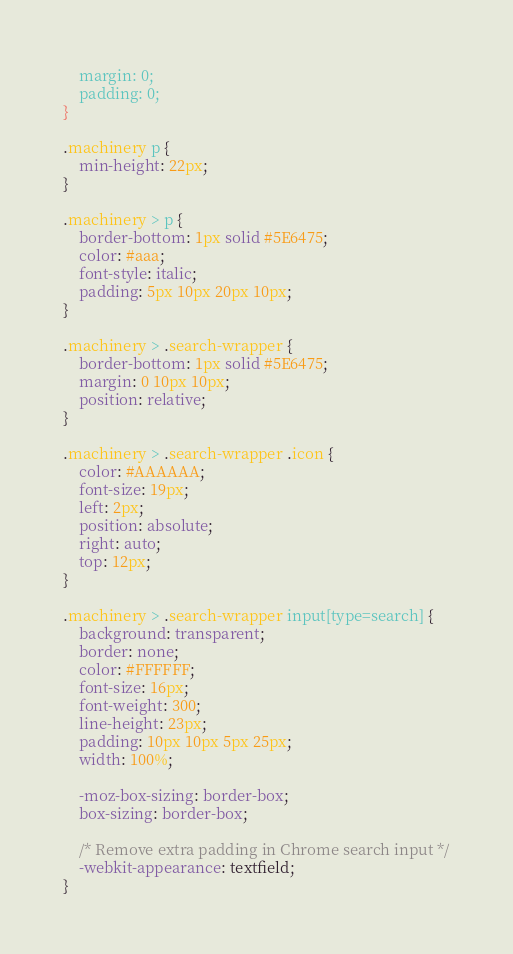<code> <loc_0><loc_0><loc_500><loc_500><_CSS_>    margin: 0;
    padding: 0;
}

.machinery p {
    min-height: 22px;
}

.machinery > p {
    border-bottom: 1px solid #5E6475;
    color: #aaa;
    font-style: italic;
    padding: 5px 10px 20px 10px;
}

.machinery > .search-wrapper {
    border-bottom: 1px solid #5E6475;
    margin: 0 10px 10px;
    position: relative;
}

.machinery > .search-wrapper .icon {
    color: #AAAAAA;
    font-size: 19px;
    left: 2px;
    position: absolute;
    right: auto;
    top: 12px;
}

.machinery > .search-wrapper input[type=search] {
    background: transparent;
    border: none;
    color: #FFFFFF;
    font-size: 16px;
    font-weight: 300;
    line-height: 23px;
    padding: 10px 10px 5px 25px;
    width: 100%;

    -moz-box-sizing: border-box;
    box-sizing: border-box;

    /* Remove extra padding in Chrome search input */
    -webkit-appearance: textfield;
}
</code> 